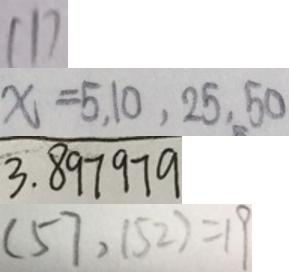<formula> <loc_0><loc_0><loc_500><loc_500>1 1 7 
 x = 5 , 1 0 , 2 5 , 5 0 
 3 . 8 9 7 9 7 9 
 ( 5 7 , 1 5 2 ) = 1 9</formula> 